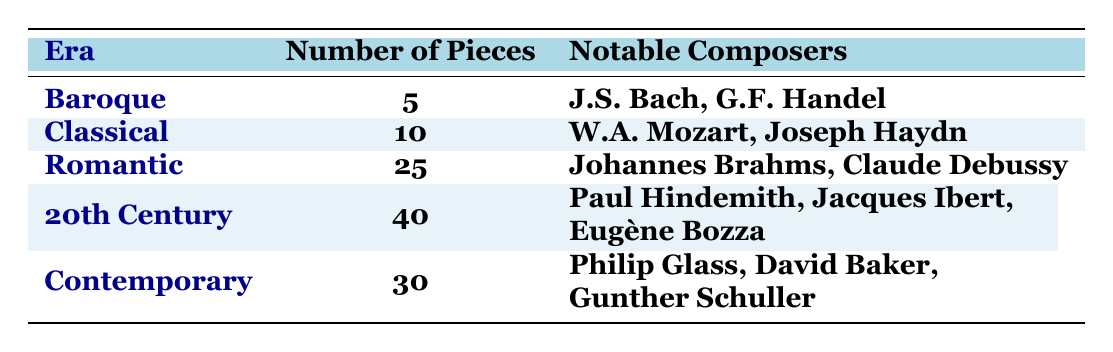What is the total number of classical saxophone compositions listed in the table? To find the total, we need to sum the number of pieces from all eras: 5 (Baroque) + 10 (Classical) + 25 (Romantic) + 40 (20th Century) + 30 (Contemporary) = 110.
Answer: 110 Which era has the highest number of compositions? By comparing the numbers of pieces in each era, we see that the 20th Century has 40 pieces, which is higher than all other eras.
Answer: 20th Century How many notable composers are associated with the Romantic era? The table lists two notable composers for the Romantic era, which are Johannes Brahms and Claude Debussy.
Answer: 2 What is the difference in the number of pieces between the Classical and Romantic eras? To find the difference, subtract the number of pieces in the Classical era (10) from the number in the Romantic era (25): 25 - 10 = 15.
Answer: 15 Are there more pieces in the Contemporary era than in the Baroque era? The Contemporary era has 30 pieces while the Baroque era has 5; since 30 is greater than 5, the statement is true.
Answer: Yes What is the average number of pieces per era? To calculate the average, we sum the number of pieces (110) and divide by the number of eras (5): 110 / 5 = 22.
Answer: 22 Which era, besides the 20th Century, has over 20 compositions? The only era with more than 20 pieces, apart from the 20th Century (40), is the Romantic era, which has 25 pieces.
Answer: Romantic Is there a greater variety of notable composers in the 20th Century compared to the Baroque era? The 20th Century lists three notable composers while the Baroque era lists only two, indicating a greater variety in the 20th Century.
Answer: Yes What is the total number of notable composers listed across all eras? By counting the notable composers per era, we find 2 (Baroque) + 2 (Classical) + 2 (Romantic) + 3 (20th Century) + 3 (Contemporary) = 12.
Answer: 12 Which era has the least number of compositions, and how many are there? The era with the least number of compositions is the Baroque era, which has 5 pieces.
Answer: Baroque, 5 